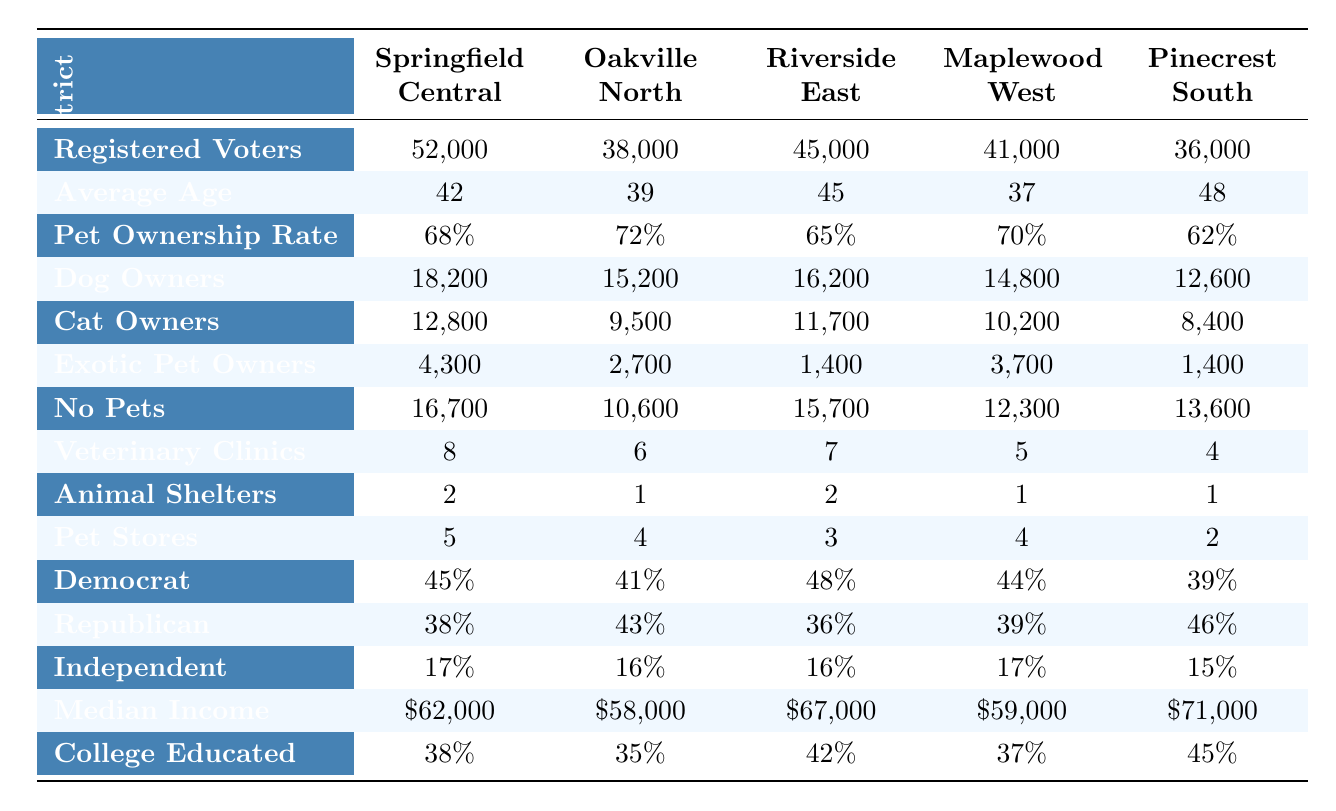What is the pet ownership rate in Riverside East? The table indicates that the pet ownership rate for Riverside East is listed directly, which shows as 65%.
Answer: 65% Which district has the highest number of dog owners? By comparing the number of dog owners across all districts, Springfield Central has 18,200 dog owners, which is more than any other district.
Answer: Springfield Central How many registered voters are there in Pinecrest South? The table provides the number of registered voters for Pinecrest South, which is 36,000.
Answer: 36,000 What percentage of registered voters in Oakville North are affiliated with the Republican party? The table lists the party affiliation for Oakville North, with Republican affiliation at 43%.
Answer: 43% Which district has the lowest average age? By looking at the average age column, Maplewood West has the lowest average age at 37 years.
Answer: Maplewood West How many total cat owners are there across all districts? To find the total cat owners, sum the values: 12,800 (Springfield Central) + 9,500 (Oakville North) + 11,700 (Riverside East) + 10,200 (Maplewood West) + 8,400 (Pinecrest South) = 52,600.
Answer: 52,600 Is the number of veterinary clinics in Riverside East greater than in Oakville North? The table shows 7 veterinary clinics in Riverside East and 6 in Oakville North, making it true that Riverside East has more clinics.
Answer: Yes What is the difference in median income between Pinecrest South and Oakville North? To find the difference, subtract the median income of Oakville North (58,000) from Pinecrest South (71,000): 71,000 - 58,000 = 13,000.
Answer: $13,000 Which district has the highest rate of college-educated individuals? By checking the college-educated percentages, Pinecrest South has the highest rate at 45%.
Answer: Pinecrest South If the average age of dog owners in Springfield Central and Riverside East is calculated, what would that be? The average age of dog owners can be approximated using the average ages of the districts: (42 + 45) / 2 = 43.5. Thus, rounding gives an average of about 44.
Answer: 44 